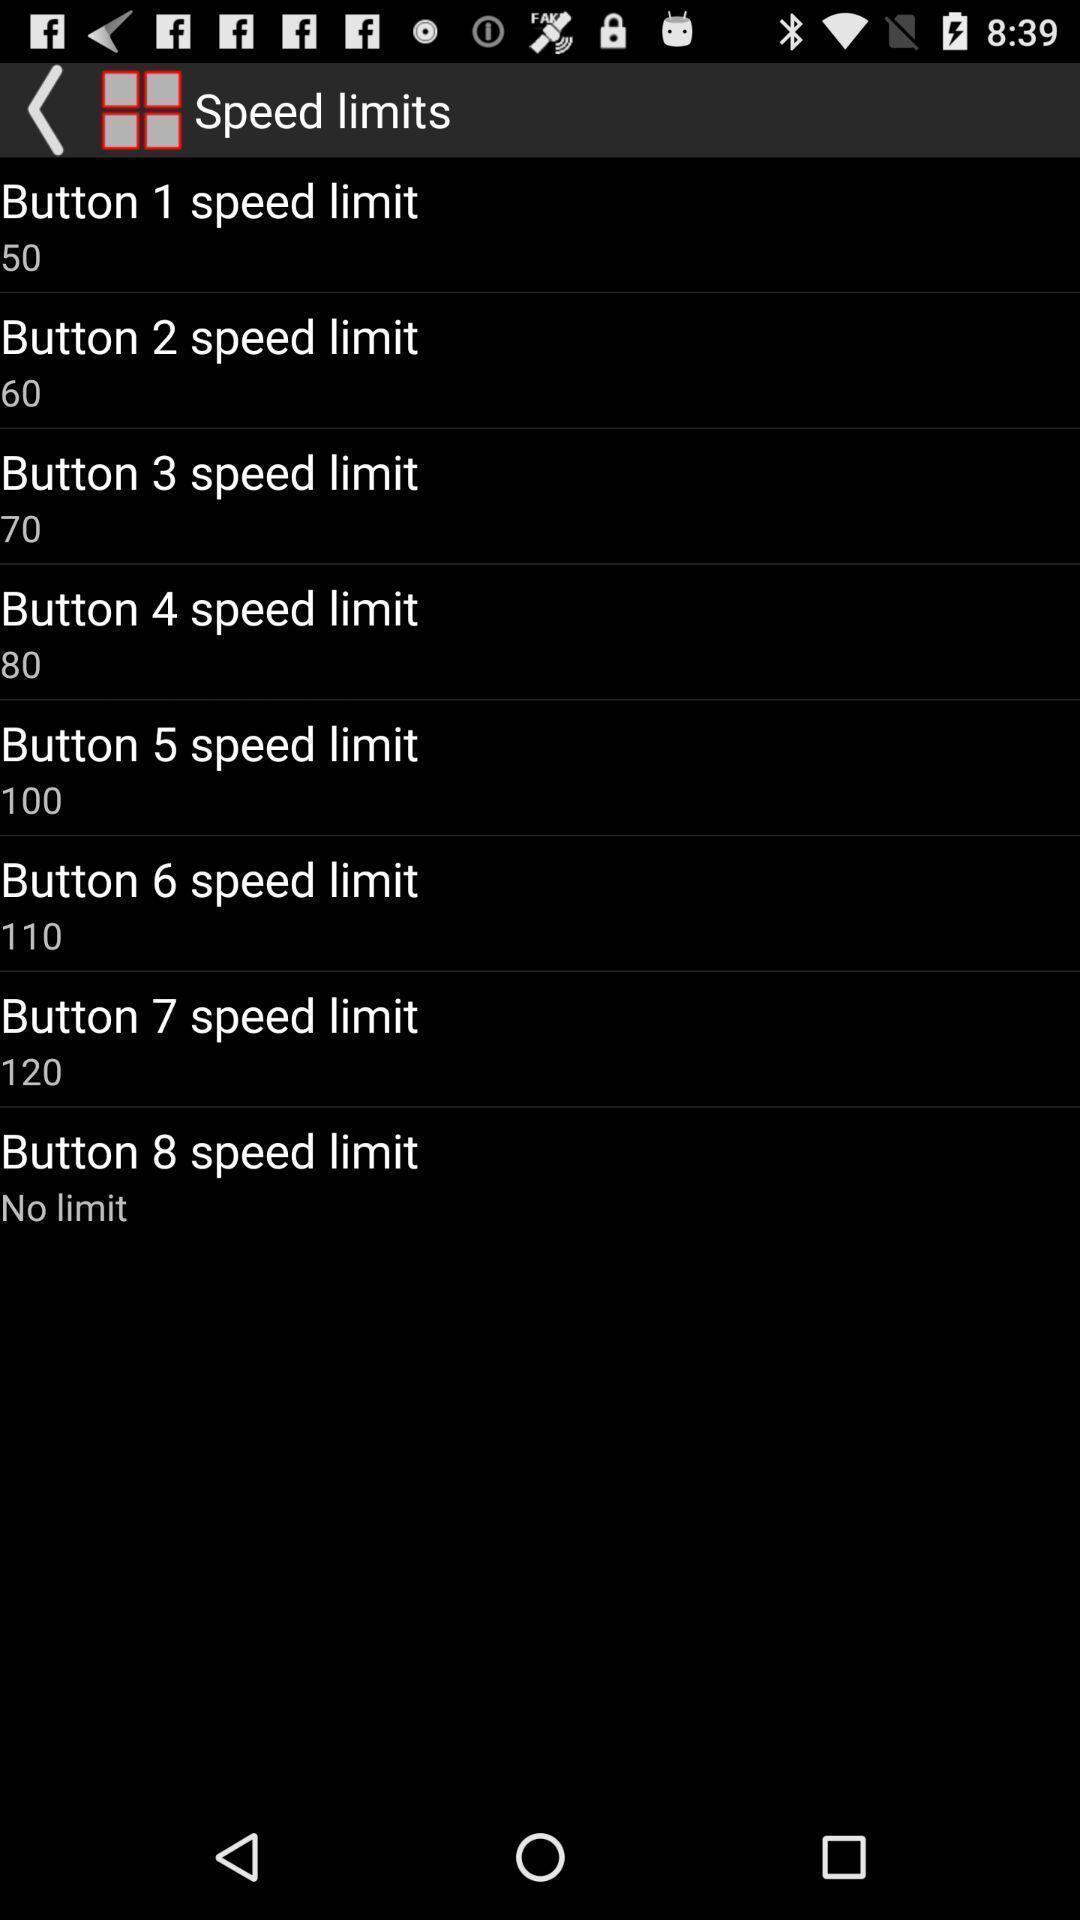Describe the visual elements of this screenshot. Screen showing list of buttons with speed limits. 